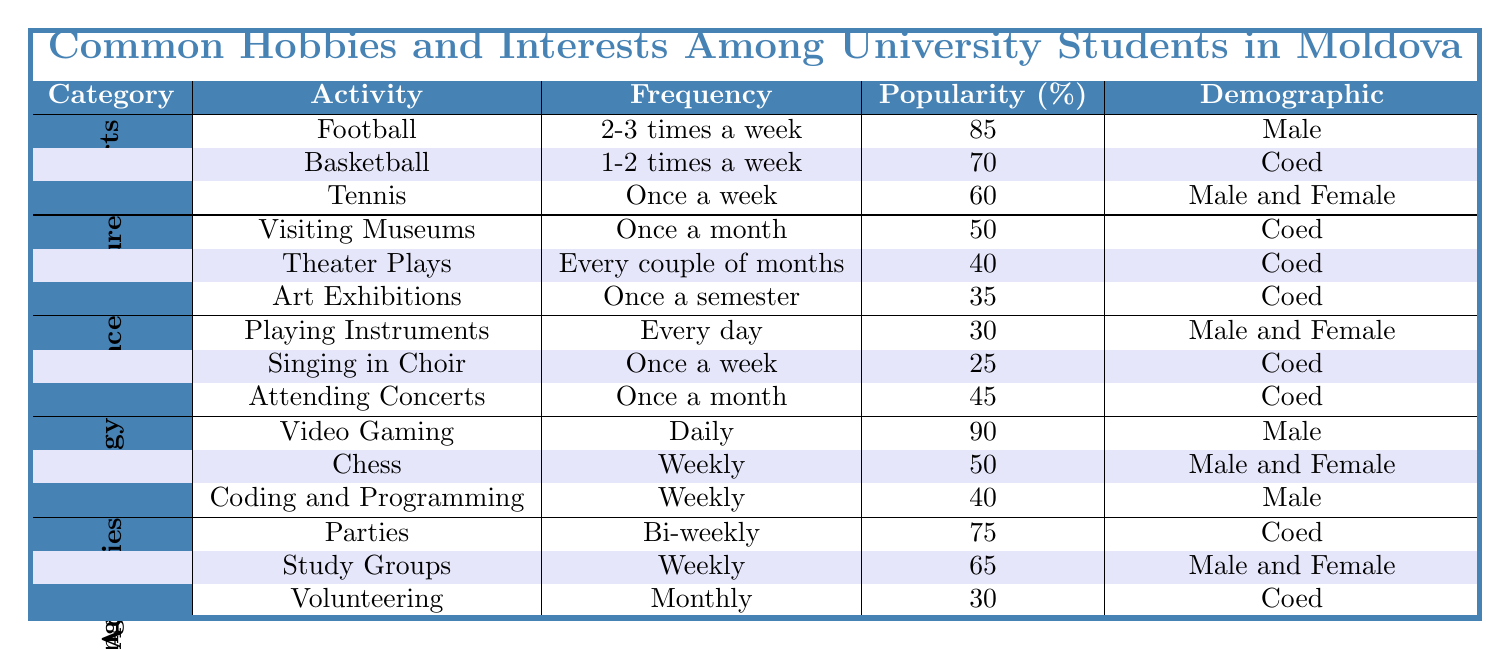What is the most popular sport among university students in Moldova? The table indicates that Football has the highest popularity at 85%.
Answer: 85% How often do students engage in parties? According to the table, parties are held bi-weekly, meaning every two weeks.
Answer: Bi-weekly Which activity has the lowest popularity in the Arts & Culture category? Art Exhibitions have a popularity rate of 35%, which is the lowest in that category.
Answer: 35% Do more students attend theater plays than visit museums? The popularity of visiting museums is 50%, while theater plays have a popularity of 40%, so more students visit museums.
Answer: Yes What is the frequency of playing instruments among university students? The table shows that playing instruments occurs every day.
Answer: Every day How many activities have a popularity greater than or equal to 50% in the Gaming & Technology category? Video Gaming (90%) and Chess (50%) both have popularity rates of 50% or greater, resulting in a total of 2 activities.
Answer: 2 What is the average frequency of social activities listed in the table? The frequencies for social activities are bi-weekly (which can be seen as every 2 weeks), weekly (1 time per week), and monthly (1 time per month). To average these, we consider each frequency in weeks: bi-weekly = 2 weeks, weekly = 1 week, and monthly approximately = 4 weeks. The average is (2 + 1 + 4) / 3 = 2.33 weeks, which is roughly 2 weeks and 2 days.
Answer: Roughly 2 weeks and 2 days Is there any activity in the Music & Performance category that is more popular than attending concerts? Attending Concerts has a popularity of 45%. Playing Instruments (30%) and Singing in Choir (25%) are both less popular, so there isn't any activity more popular than attending concerts in that category.
Answer: No What demographic participates in basketball? The table shows that basketball is categorized as Coed, meaning both male and female students participate.
Answer: Coed In the Sports category, how does the popularity of Tennis compare to Basketball? Tennis has a popularity of 60% while Basketball has a popularity of 70%. Since 60% is less than 70%, Tennis is less popular than Basketball.
Answer: Tennis is less popular than Basketball 